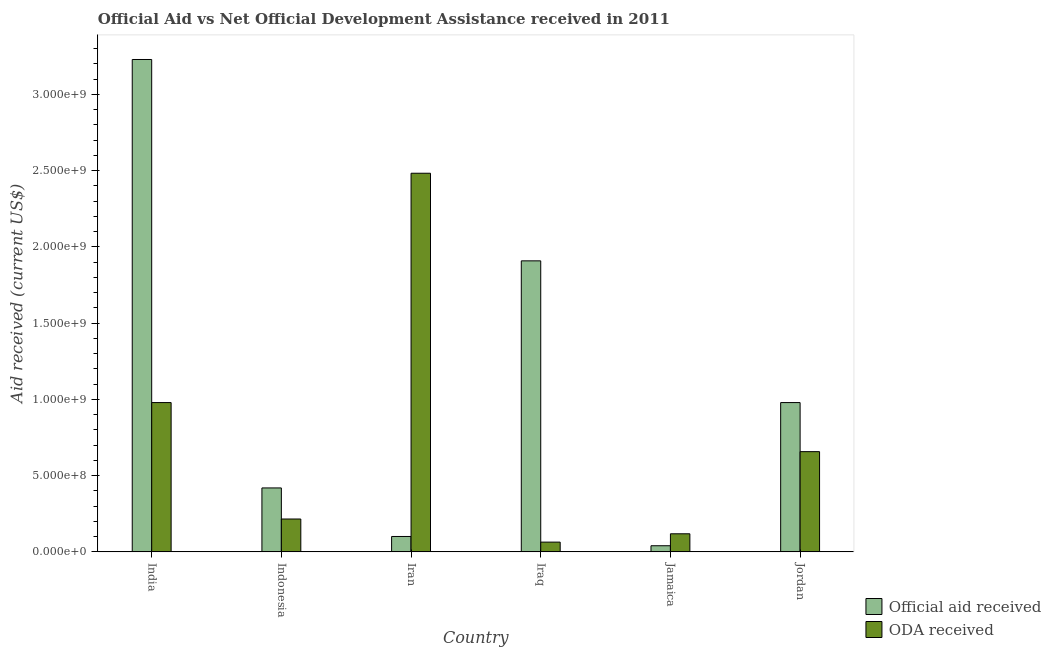How many groups of bars are there?
Provide a short and direct response. 6. Are the number of bars per tick equal to the number of legend labels?
Ensure brevity in your answer.  Yes. What is the label of the 6th group of bars from the left?
Offer a very short reply. Jordan. In how many cases, is the number of bars for a given country not equal to the number of legend labels?
Keep it short and to the point. 0. What is the oda received in Jamaica?
Your answer should be very brief. 1.19e+08. Across all countries, what is the maximum oda received?
Ensure brevity in your answer.  2.48e+09. Across all countries, what is the minimum oda received?
Ensure brevity in your answer.  6.39e+07. In which country was the official aid received maximum?
Keep it short and to the point. India. In which country was the official aid received minimum?
Your response must be concise. Jamaica. What is the total official aid received in the graph?
Your answer should be very brief. 6.68e+09. What is the difference between the oda received in India and that in Iran?
Offer a terse response. -1.50e+09. What is the difference between the official aid received in Iraq and the oda received in Jamaica?
Give a very brief answer. 1.79e+09. What is the average oda received per country?
Your response must be concise. 7.53e+08. What is the difference between the official aid received and oda received in Indonesia?
Give a very brief answer. 2.04e+08. In how many countries, is the official aid received greater than 500000000 US$?
Offer a terse response. 3. What is the ratio of the oda received in Iraq to that in Jamaica?
Give a very brief answer. 0.54. What is the difference between the highest and the second highest official aid received?
Make the answer very short. 1.32e+09. What is the difference between the highest and the lowest oda received?
Provide a succinct answer. 2.42e+09. In how many countries, is the official aid received greater than the average official aid received taken over all countries?
Offer a terse response. 2. Is the sum of the oda received in Indonesia and Jamaica greater than the maximum official aid received across all countries?
Keep it short and to the point. No. What does the 2nd bar from the left in Indonesia represents?
Keep it short and to the point. ODA received. What does the 1st bar from the right in Jamaica represents?
Give a very brief answer. ODA received. How many bars are there?
Ensure brevity in your answer.  12. Are all the bars in the graph horizontal?
Provide a short and direct response. No. What is the difference between two consecutive major ticks on the Y-axis?
Keep it short and to the point. 5.00e+08. Are the values on the major ticks of Y-axis written in scientific E-notation?
Give a very brief answer. Yes. How are the legend labels stacked?
Provide a short and direct response. Vertical. What is the title of the graph?
Provide a succinct answer. Official Aid vs Net Official Development Assistance received in 2011 . Does "Males" appear as one of the legend labels in the graph?
Provide a short and direct response. No. What is the label or title of the X-axis?
Your answer should be compact. Country. What is the label or title of the Y-axis?
Provide a succinct answer. Aid received (current US$). What is the Aid received (current US$) in Official aid received in India?
Offer a terse response. 3.23e+09. What is the Aid received (current US$) in ODA received in India?
Give a very brief answer. 9.79e+08. What is the Aid received (current US$) of Official aid received in Indonesia?
Ensure brevity in your answer.  4.19e+08. What is the Aid received (current US$) in ODA received in Indonesia?
Provide a succinct answer. 2.16e+08. What is the Aid received (current US$) in Official aid received in Iran?
Your answer should be compact. 1.01e+08. What is the Aid received (current US$) of ODA received in Iran?
Your answer should be very brief. 2.48e+09. What is the Aid received (current US$) of Official aid received in Iraq?
Your answer should be compact. 1.91e+09. What is the Aid received (current US$) in ODA received in Iraq?
Offer a terse response. 6.39e+07. What is the Aid received (current US$) in Official aid received in Jamaica?
Make the answer very short. 4.02e+07. What is the Aid received (current US$) of ODA received in Jamaica?
Provide a short and direct response. 1.19e+08. What is the Aid received (current US$) in Official aid received in Jordan?
Make the answer very short. 9.79e+08. What is the Aid received (current US$) of ODA received in Jordan?
Offer a terse response. 6.57e+08. Across all countries, what is the maximum Aid received (current US$) in Official aid received?
Your answer should be compact. 3.23e+09. Across all countries, what is the maximum Aid received (current US$) in ODA received?
Offer a very short reply. 2.48e+09. Across all countries, what is the minimum Aid received (current US$) in Official aid received?
Provide a short and direct response. 4.02e+07. Across all countries, what is the minimum Aid received (current US$) in ODA received?
Your answer should be compact. 6.39e+07. What is the total Aid received (current US$) in Official aid received in the graph?
Keep it short and to the point. 6.68e+09. What is the total Aid received (current US$) in ODA received in the graph?
Your answer should be very brief. 4.52e+09. What is the difference between the Aid received (current US$) in Official aid received in India and that in Indonesia?
Make the answer very short. 2.81e+09. What is the difference between the Aid received (current US$) in ODA received in India and that in Indonesia?
Give a very brief answer. 7.63e+08. What is the difference between the Aid received (current US$) of Official aid received in India and that in Iran?
Keep it short and to the point. 3.13e+09. What is the difference between the Aid received (current US$) of ODA received in India and that in Iran?
Offer a terse response. -1.50e+09. What is the difference between the Aid received (current US$) of Official aid received in India and that in Iraq?
Ensure brevity in your answer.  1.32e+09. What is the difference between the Aid received (current US$) of ODA received in India and that in Iraq?
Offer a very short reply. 9.15e+08. What is the difference between the Aid received (current US$) in Official aid received in India and that in Jamaica?
Provide a succinct answer. 3.19e+09. What is the difference between the Aid received (current US$) in ODA received in India and that in Jamaica?
Provide a short and direct response. 8.60e+08. What is the difference between the Aid received (current US$) of Official aid received in India and that in Jordan?
Make the answer very short. 2.25e+09. What is the difference between the Aid received (current US$) in ODA received in India and that in Jordan?
Keep it short and to the point. 3.22e+08. What is the difference between the Aid received (current US$) in Official aid received in Indonesia and that in Iran?
Your answer should be very brief. 3.18e+08. What is the difference between the Aid received (current US$) of ODA received in Indonesia and that in Iran?
Ensure brevity in your answer.  -2.27e+09. What is the difference between the Aid received (current US$) of Official aid received in Indonesia and that in Iraq?
Your answer should be very brief. -1.49e+09. What is the difference between the Aid received (current US$) in ODA received in Indonesia and that in Iraq?
Offer a terse response. 1.52e+08. What is the difference between the Aid received (current US$) of Official aid received in Indonesia and that in Jamaica?
Give a very brief answer. 3.79e+08. What is the difference between the Aid received (current US$) of ODA received in Indonesia and that in Jamaica?
Give a very brief answer. 9.69e+07. What is the difference between the Aid received (current US$) in Official aid received in Indonesia and that in Jordan?
Your response must be concise. -5.60e+08. What is the difference between the Aid received (current US$) of ODA received in Indonesia and that in Jordan?
Give a very brief answer. -4.42e+08. What is the difference between the Aid received (current US$) in Official aid received in Iran and that in Iraq?
Offer a terse response. -1.81e+09. What is the difference between the Aid received (current US$) of ODA received in Iran and that in Iraq?
Your answer should be compact. 2.42e+09. What is the difference between the Aid received (current US$) of Official aid received in Iran and that in Jamaica?
Your response must be concise. 6.07e+07. What is the difference between the Aid received (current US$) of ODA received in Iran and that in Jamaica?
Your answer should be compact. 2.36e+09. What is the difference between the Aid received (current US$) in Official aid received in Iran and that in Jordan?
Provide a succinct answer. -8.78e+08. What is the difference between the Aid received (current US$) of ODA received in Iran and that in Jordan?
Make the answer very short. 1.83e+09. What is the difference between the Aid received (current US$) in Official aid received in Iraq and that in Jamaica?
Offer a very short reply. 1.87e+09. What is the difference between the Aid received (current US$) of ODA received in Iraq and that in Jamaica?
Ensure brevity in your answer.  -5.46e+07. What is the difference between the Aid received (current US$) in Official aid received in Iraq and that in Jordan?
Offer a very short reply. 9.29e+08. What is the difference between the Aid received (current US$) of ODA received in Iraq and that in Jordan?
Give a very brief answer. -5.93e+08. What is the difference between the Aid received (current US$) of Official aid received in Jamaica and that in Jordan?
Provide a succinct answer. -9.39e+08. What is the difference between the Aid received (current US$) of ODA received in Jamaica and that in Jordan?
Keep it short and to the point. -5.39e+08. What is the difference between the Aid received (current US$) of Official aid received in India and the Aid received (current US$) of ODA received in Indonesia?
Provide a succinct answer. 3.01e+09. What is the difference between the Aid received (current US$) in Official aid received in India and the Aid received (current US$) in ODA received in Iran?
Offer a very short reply. 7.46e+08. What is the difference between the Aid received (current US$) in Official aid received in India and the Aid received (current US$) in ODA received in Iraq?
Your response must be concise. 3.16e+09. What is the difference between the Aid received (current US$) of Official aid received in India and the Aid received (current US$) of ODA received in Jamaica?
Give a very brief answer. 3.11e+09. What is the difference between the Aid received (current US$) in Official aid received in India and the Aid received (current US$) in ODA received in Jordan?
Your response must be concise. 2.57e+09. What is the difference between the Aid received (current US$) of Official aid received in Indonesia and the Aid received (current US$) of ODA received in Iran?
Your answer should be compact. -2.06e+09. What is the difference between the Aid received (current US$) of Official aid received in Indonesia and the Aid received (current US$) of ODA received in Iraq?
Your answer should be compact. 3.55e+08. What is the difference between the Aid received (current US$) of Official aid received in Indonesia and the Aid received (current US$) of ODA received in Jamaica?
Your answer should be compact. 3.01e+08. What is the difference between the Aid received (current US$) of Official aid received in Indonesia and the Aid received (current US$) of ODA received in Jordan?
Your answer should be compact. -2.38e+08. What is the difference between the Aid received (current US$) in Official aid received in Iran and the Aid received (current US$) in ODA received in Iraq?
Make the answer very short. 3.70e+07. What is the difference between the Aid received (current US$) in Official aid received in Iran and the Aid received (current US$) in ODA received in Jamaica?
Your answer should be compact. -1.76e+07. What is the difference between the Aid received (current US$) of Official aid received in Iran and the Aid received (current US$) of ODA received in Jordan?
Give a very brief answer. -5.56e+08. What is the difference between the Aid received (current US$) of Official aid received in Iraq and the Aid received (current US$) of ODA received in Jamaica?
Provide a short and direct response. 1.79e+09. What is the difference between the Aid received (current US$) in Official aid received in Iraq and the Aid received (current US$) in ODA received in Jordan?
Make the answer very short. 1.25e+09. What is the difference between the Aid received (current US$) in Official aid received in Jamaica and the Aid received (current US$) in ODA received in Jordan?
Offer a very short reply. -6.17e+08. What is the average Aid received (current US$) in Official aid received per country?
Your answer should be compact. 1.11e+09. What is the average Aid received (current US$) in ODA received per country?
Provide a succinct answer. 7.53e+08. What is the difference between the Aid received (current US$) in Official aid received and Aid received (current US$) in ODA received in India?
Your answer should be very brief. 2.25e+09. What is the difference between the Aid received (current US$) in Official aid received and Aid received (current US$) in ODA received in Indonesia?
Keep it short and to the point. 2.04e+08. What is the difference between the Aid received (current US$) in Official aid received and Aid received (current US$) in ODA received in Iran?
Keep it short and to the point. -2.38e+09. What is the difference between the Aid received (current US$) in Official aid received and Aid received (current US$) in ODA received in Iraq?
Provide a short and direct response. 1.84e+09. What is the difference between the Aid received (current US$) in Official aid received and Aid received (current US$) in ODA received in Jamaica?
Offer a very short reply. -7.83e+07. What is the difference between the Aid received (current US$) of Official aid received and Aid received (current US$) of ODA received in Jordan?
Your answer should be compact. 3.22e+08. What is the ratio of the Aid received (current US$) of Official aid received in India to that in Indonesia?
Your response must be concise. 7.7. What is the ratio of the Aid received (current US$) of ODA received in India to that in Indonesia?
Make the answer very short. 4.54. What is the ratio of the Aid received (current US$) in Official aid received in India to that in Iran?
Provide a short and direct response. 31.98. What is the ratio of the Aid received (current US$) in ODA received in India to that in Iran?
Keep it short and to the point. 0.39. What is the ratio of the Aid received (current US$) of Official aid received in India to that in Iraq?
Offer a terse response. 1.69. What is the ratio of the Aid received (current US$) of ODA received in India to that in Iraq?
Make the answer very short. 15.31. What is the ratio of the Aid received (current US$) of Official aid received in India to that in Jamaica?
Your answer should be very brief. 80.2. What is the ratio of the Aid received (current US$) of ODA received in India to that in Jamaica?
Offer a terse response. 8.26. What is the ratio of the Aid received (current US$) of Official aid received in India to that in Jordan?
Provide a short and direct response. 3.3. What is the ratio of the Aid received (current US$) in ODA received in India to that in Jordan?
Ensure brevity in your answer.  1.49. What is the ratio of the Aid received (current US$) in Official aid received in Indonesia to that in Iran?
Provide a succinct answer. 4.15. What is the ratio of the Aid received (current US$) of ODA received in Indonesia to that in Iran?
Make the answer very short. 0.09. What is the ratio of the Aid received (current US$) in Official aid received in Indonesia to that in Iraq?
Give a very brief answer. 0.22. What is the ratio of the Aid received (current US$) of ODA received in Indonesia to that in Iraq?
Offer a terse response. 3.37. What is the ratio of the Aid received (current US$) of Official aid received in Indonesia to that in Jamaica?
Provide a short and direct response. 10.42. What is the ratio of the Aid received (current US$) in ODA received in Indonesia to that in Jamaica?
Give a very brief answer. 1.82. What is the ratio of the Aid received (current US$) of Official aid received in Indonesia to that in Jordan?
Provide a succinct answer. 0.43. What is the ratio of the Aid received (current US$) of ODA received in Indonesia to that in Jordan?
Provide a succinct answer. 0.33. What is the ratio of the Aid received (current US$) in Official aid received in Iran to that in Iraq?
Ensure brevity in your answer.  0.05. What is the ratio of the Aid received (current US$) in ODA received in Iran to that in Iraq?
Make the answer very short. 38.83. What is the ratio of the Aid received (current US$) in Official aid received in Iran to that in Jamaica?
Offer a very short reply. 2.51. What is the ratio of the Aid received (current US$) of ODA received in Iran to that in Jamaica?
Offer a very short reply. 20.93. What is the ratio of the Aid received (current US$) in Official aid received in Iran to that in Jordan?
Your answer should be compact. 0.1. What is the ratio of the Aid received (current US$) of ODA received in Iran to that in Jordan?
Provide a succinct answer. 3.78. What is the ratio of the Aid received (current US$) of Official aid received in Iraq to that in Jamaica?
Ensure brevity in your answer.  47.41. What is the ratio of the Aid received (current US$) of ODA received in Iraq to that in Jamaica?
Your answer should be compact. 0.54. What is the ratio of the Aid received (current US$) in Official aid received in Iraq to that in Jordan?
Provide a succinct answer. 1.95. What is the ratio of the Aid received (current US$) in ODA received in Iraq to that in Jordan?
Ensure brevity in your answer.  0.1. What is the ratio of the Aid received (current US$) of Official aid received in Jamaica to that in Jordan?
Provide a short and direct response. 0.04. What is the ratio of the Aid received (current US$) of ODA received in Jamaica to that in Jordan?
Provide a short and direct response. 0.18. What is the difference between the highest and the second highest Aid received (current US$) of Official aid received?
Make the answer very short. 1.32e+09. What is the difference between the highest and the second highest Aid received (current US$) in ODA received?
Offer a terse response. 1.50e+09. What is the difference between the highest and the lowest Aid received (current US$) of Official aid received?
Your response must be concise. 3.19e+09. What is the difference between the highest and the lowest Aid received (current US$) of ODA received?
Offer a terse response. 2.42e+09. 